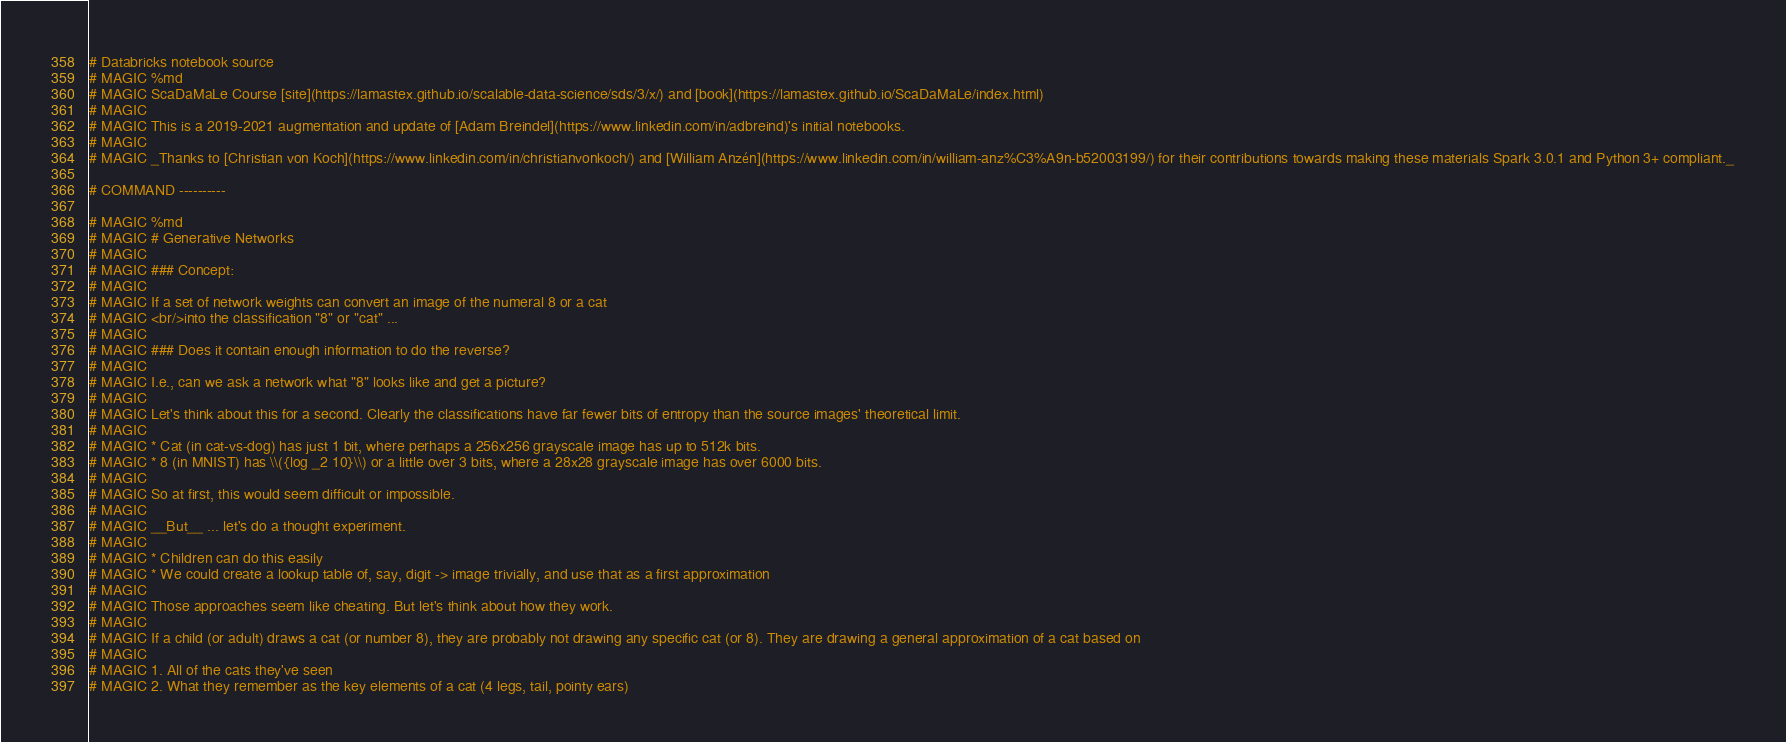Convert code to text. <code><loc_0><loc_0><loc_500><loc_500><_Python_># Databricks notebook source
# MAGIC %md
# MAGIC ScaDaMaLe Course [site](https://lamastex.github.io/scalable-data-science/sds/3/x/) and [book](https://lamastex.github.io/ScaDaMaLe/index.html)
# MAGIC 
# MAGIC This is a 2019-2021 augmentation and update of [Adam Breindel](https://www.linkedin.com/in/adbreind)'s initial notebooks.
# MAGIC 
# MAGIC _Thanks to [Christian von Koch](https://www.linkedin.com/in/christianvonkoch/) and [William Anzén](https://www.linkedin.com/in/william-anz%C3%A9n-b52003199/) for their contributions towards making these materials Spark 3.0.1 and Python 3+ compliant._

# COMMAND ----------

# MAGIC %md 
# MAGIC # Generative Networks
# MAGIC 
# MAGIC ### Concept:
# MAGIC 
# MAGIC If a set of network weights can convert an image of the numeral 8 or a cat
# MAGIC <br/>into the classification "8" or "cat" ... 
# MAGIC 
# MAGIC ### Does it contain enough information to do the reverse?
# MAGIC 
# MAGIC I.e., can we ask a network what "8" looks like and get a picture?
# MAGIC 
# MAGIC Let's think about this for a second. Clearly the classifications have far fewer bits of entropy than the source images' theoretical limit.
# MAGIC 
# MAGIC * Cat (in cat-vs-dog) has just 1 bit, where perhaps a 256x256 grayscale image has up to 512k bits.
# MAGIC * 8 (in MNIST) has \\({log _2 10}\\) or a little over 3 bits, where a 28x28 grayscale image has over 6000 bits.
# MAGIC 
# MAGIC So at first, this would seem difficult or impossible.
# MAGIC 
# MAGIC __But__ ... let's do a thought experiment.
# MAGIC 
# MAGIC * Children can do this easily
# MAGIC * We could create a lookup table of, say, digit -> image trivially, and use that as a first approximation
# MAGIC 
# MAGIC Those approaches seem like cheating. But let's think about how they work.
# MAGIC 
# MAGIC If a child (or adult) draws a cat (or number 8), they are probably not drawing any specific cat (or 8). They are drawing a general approximation of a cat based on 
# MAGIC 
# MAGIC 1. All of the cats they've seen
# MAGIC 2. What they remember as the key elements of a cat (4 legs, tail, pointy ears)</code> 